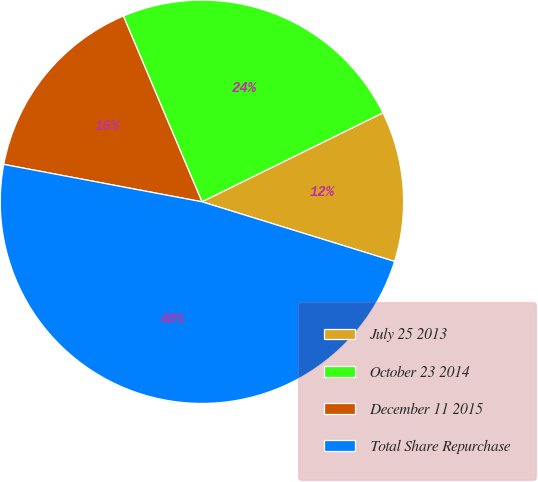<chart> <loc_0><loc_0><loc_500><loc_500><pie_chart><fcel>July 25 2013<fcel>October 23 2014<fcel>December 11 2015<fcel>Total Share Repurchase<nl><fcel>12.05%<fcel>24.1%<fcel>15.66%<fcel>48.19%<nl></chart> 